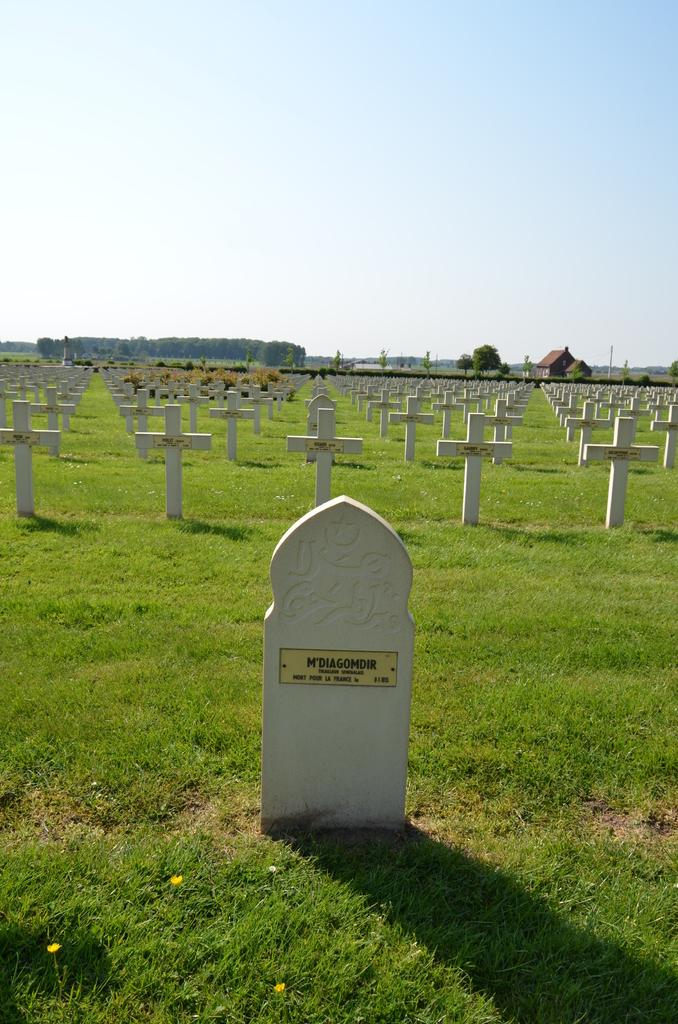What is the main subject of the image? The image depicts a graveyard. What can be seen in the background of the image? There are trees and houses in the background of the image. What type of quartz can be seen in the image? There is no quartz present in the image. How do the waves affect the appearance of the graveyard in the image? There are no waves present in the image, as it depicts a graveyard with trees and houses in the background. 